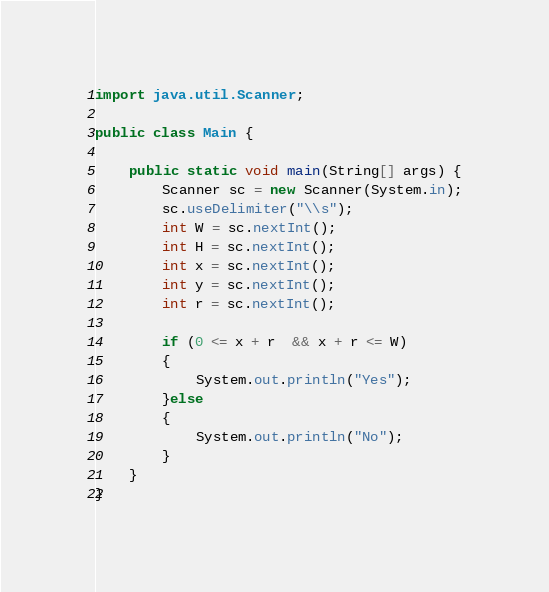Convert code to text. <code><loc_0><loc_0><loc_500><loc_500><_Java_>import java.util.Scanner;

public class Main {

	public static void main(String[] args) {
		Scanner sc = new Scanner(System.in);
		sc.useDelimiter("\\s");
		int W = sc.nextInt();
		int H = sc.nextInt();
		int x = sc.nextInt();
		int y = sc.nextInt();
		int r = sc.nextInt();
	    
		if (0 <= x + r  && x + r <= W)
		{
			System.out.println("Yes");
		}else
		{
			System.out.println("No");
		}
	}
}</code> 